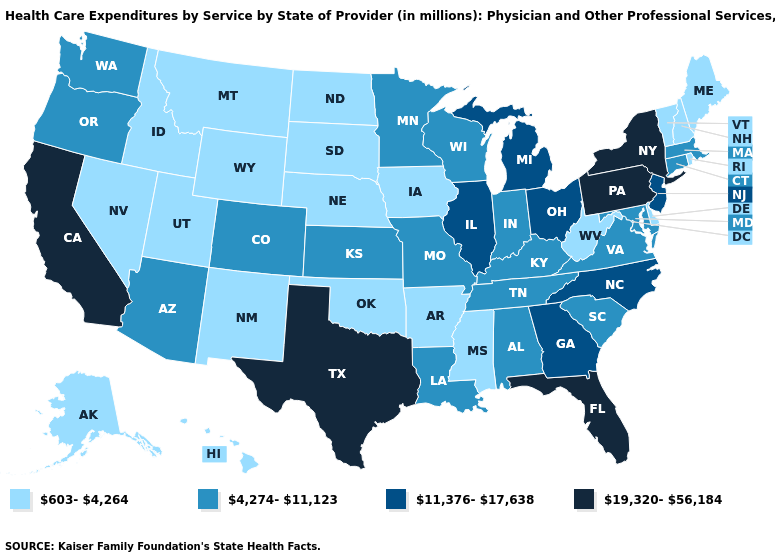How many symbols are there in the legend?
Be succinct. 4. What is the value of Utah?
Write a very short answer. 603-4,264. Name the states that have a value in the range 4,274-11,123?
Quick response, please. Alabama, Arizona, Colorado, Connecticut, Indiana, Kansas, Kentucky, Louisiana, Maryland, Massachusetts, Minnesota, Missouri, Oregon, South Carolina, Tennessee, Virginia, Washington, Wisconsin. Name the states that have a value in the range 11,376-17,638?
Answer briefly. Georgia, Illinois, Michigan, New Jersey, North Carolina, Ohio. What is the value of Tennessee?
Quick response, please. 4,274-11,123. Name the states that have a value in the range 603-4,264?
Quick response, please. Alaska, Arkansas, Delaware, Hawaii, Idaho, Iowa, Maine, Mississippi, Montana, Nebraska, Nevada, New Hampshire, New Mexico, North Dakota, Oklahoma, Rhode Island, South Dakota, Utah, Vermont, West Virginia, Wyoming. Name the states that have a value in the range 4,274-11,123?
Answer briefly. Alabama, Arizona, Colorado, Connecticut, Indiana, Kansas, Kentucky, Louisiana, Maryland, Massachusetts, Minnesota, Missouri, Oregon, South Carolina, Tennessee, Virginia, Washington, Wisconsin. Does the map have missing data?
Give a very brief answer. No. Name the states that have a value in the range 19,320-56,184?
Give a very brief answer. California, Florida, New York, Pennsylvania, Texas. What is the value of Illinois?
Quick response, please. 11,376-17,638. Which states have the lowest value in the USA?
Quick response, please. Alaska, Arkansas, Delaware, Hawaii, Idaho, Iowa, Maine, Mississippi, Montana, Nebraska, Nevada, New Hampshire, New Mexico, North Dakota, Oklahoma, Rhode Island, South Dakota, Utah, Vermont, West Virginia, Wyoming. Does Ohio have the highest value in the MidWest?
Answer briefly. Yes. What is the value of California?
Answer briefly. 19,320-56,184. What is the highest value in states that border Virginia?
Answer briefly. 11,376-17,638. Which states hav the highest value in the West?
Concise answer only. California. 